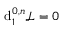Convert formula to latex. <formula><loc_0><loc_0><loc_500><loc_500>{ d } _ { 1 } ^ { 0 , n } { \mathcal { L } } = 0</formula> 